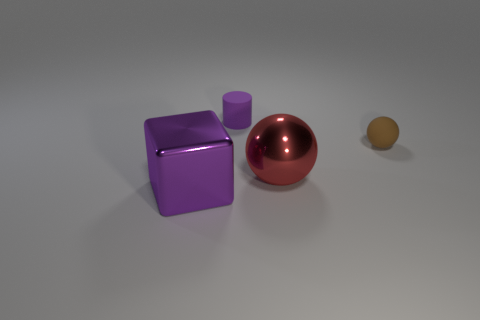Add 4 big purple metallic cylinders. How many objects exist? 8 Subtract all blocks. How many objects are left? 3 Subtract all tiny rubber cylinders. Subtract all brown matte things. How many objects are left? 2 Add 4 tiny rubber objects. How many tiny rubber objects are left? 6 Add 3 small gray blocks. How many small gray blocks exist? 3 Subtract 0 yellow cylinders. How many objects are left? 4 